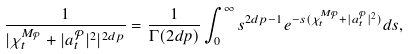<formula> <loc_0><loc_0><loc_500><loc_500>\frac { 1 } { | \chi _ { t } ^ { M _ { { \mathcal { P } } } } + | a ^ { { { \mathcal { P } } } } _ { t } | ^ { 2 } | ^ { 2 d p } } = \frac { 1 } { \Gamma ( 2 d p ) } \int _ { 0 } ^ { \infty } { s } ^ { 2 d p - 1 } e ^ { - { s } ( \chi _ { t } ^ { M _ { { \mathcal { P } } } } + | a ^ { { { \mathcal { P } } } } _ { t } | ^ { 2 } ) } d { s } ,</formula> 